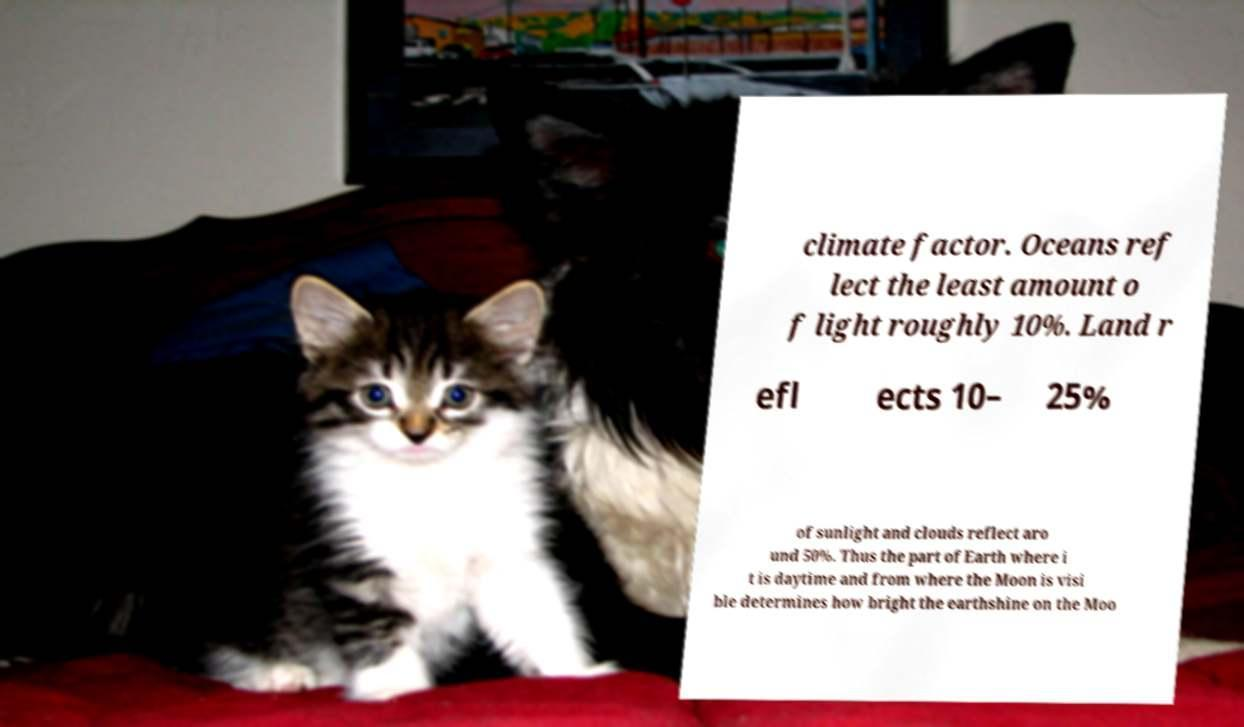For documentation purposes, I need the text within this image transcribed. Could you provide that? climate factor. Oceans ref lect the least amount o f light roughly 10%. Land r efl ects 10– 25% of sunlight and clouds reflect aro und 50%. Thus the part of Earth where i t is daytime and from where the Moon is visi ble determines how bright the earthshine on the Moo 